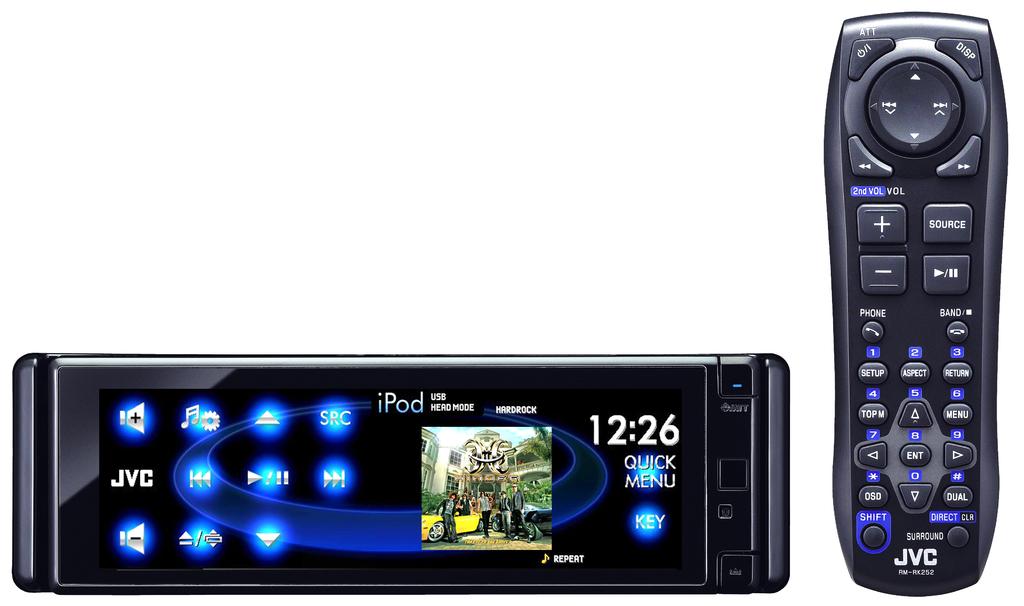What time is it?
Your answer should be compact. 12:26. 